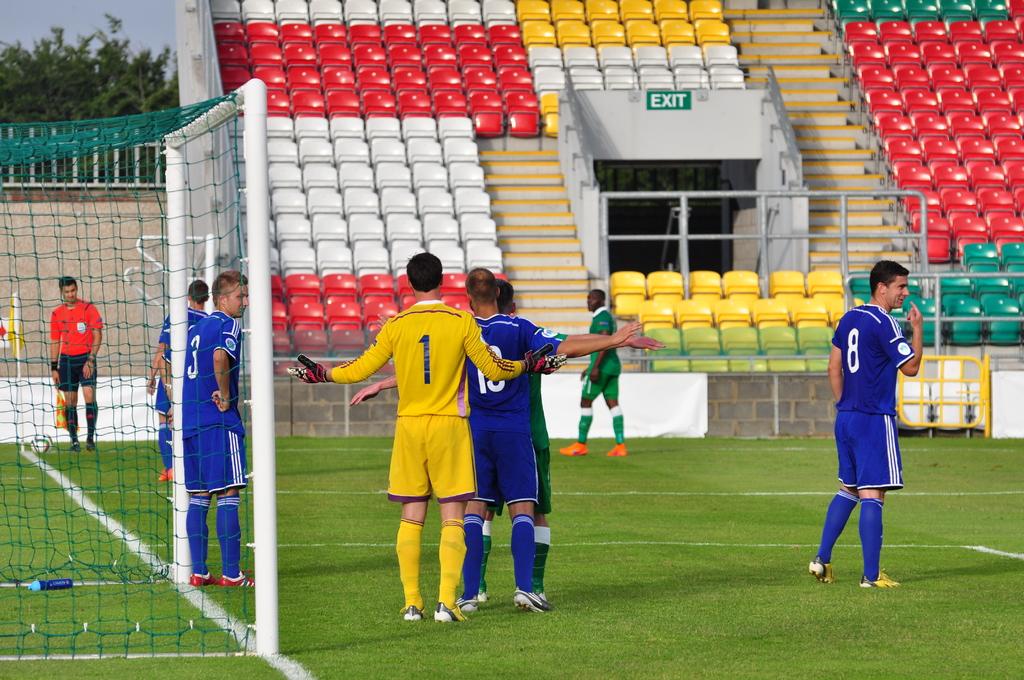What is number 1's player number?
Provide a succinct answer. 1. 